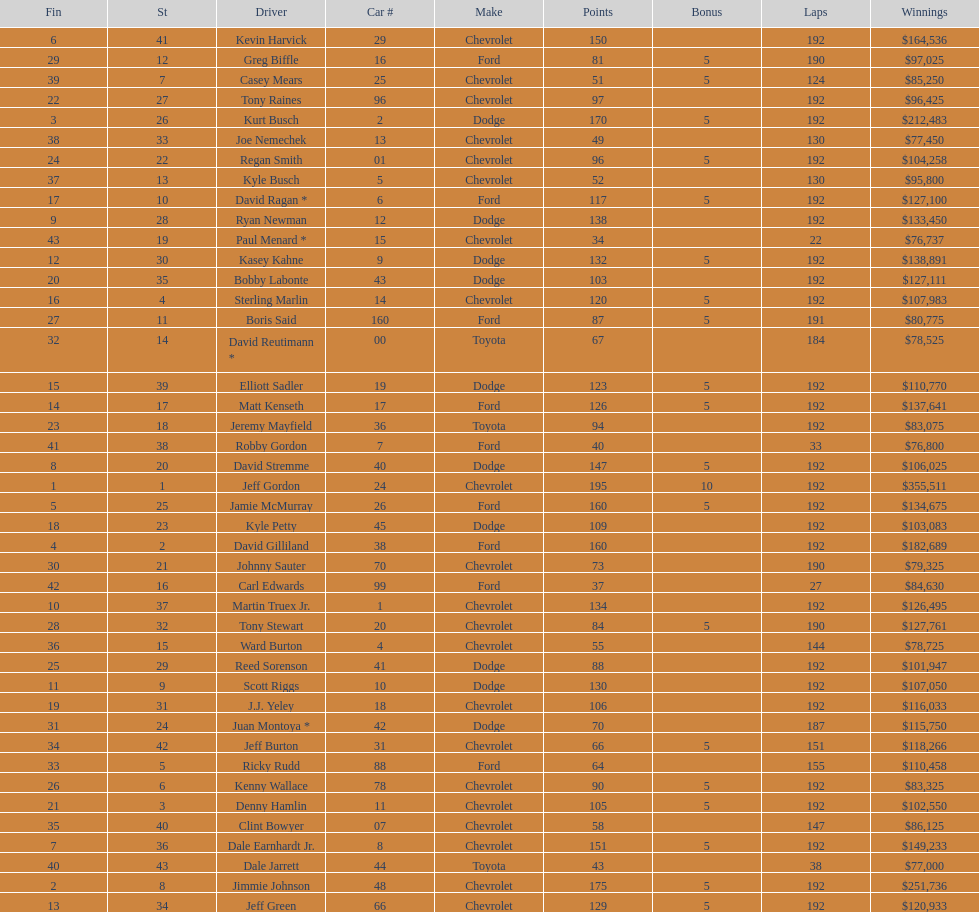What was the make of both jeff gordon's and jimmie johnson's race car? Chevrolet. Write the full table. {'header': ['Fin', 'St', 'Driver', 'Car #', 'Make', 'Points', 'Bonus', 'Laps', 'Winnings'], 'rows': [['6', '41', 'Kevin Harvick', '29', 'Chevrolet', '150', '', '192', '$164,536'], ['29', '12', 'Greg Biffle', '16', 'Ford', '81', '5', '190', '$97,025'], ['39', '7', 'Casey Mears', '25', 'Chevrolet', '51', '5', '124', '$85,250'], ['22', '27', 'Tony Raines', '96', 'Chevrolet', '97', '', '192', '$96,425'], ['3', '26', 'Kurt Busch', '2', 'Dodge', '170', '5', '192', '$212,483'], ['38', '33', 'Joe Nemechek', '13', 'Chevrolet', '49', '', '130', '$77,450'], ['24', '22', 'Regan Smith', '01', 'Chevrolet', '96', '5', '192', '$104,258'], ['37', '13', 'Kyle Busch', '5', 'Chevrolet', '52', '', '130', '$95,800'], ['17', '10', 'David Ragan *', '6', 'Ford', '117', '5', '192', '$127,100'], ['9', '28', 'Ryan Newman', '12', 'Dodge', '138', '', '192', '$133,450'], ['43', '19', 'Paul Menard *', '15', 'Chevrolet', '34', '', '22', '$76,737'], ['12', '30', 'Kasey Kahne', '9', 'Dodge', '132', '5', '192', '$138,891'], ['20', '35', 'Bobby Labonte', '43', 'Dodge', '103', '', '192', '$127,111'], ['16', '4', 'Sterling Marlin', '14', 'Chevrolet', '120', '5', '192', '$107,983'], ['27', '11', 'Boris Said', '160', 'Ford', '87', '5', '191', '$80,775'], ['32', '14', 'David Reutimann *', '00', 'Toyota', '67', '', '184', '$78,525'], ['15', '39', 'Elliott Sadler', '19', 'Dodge', '123', '5', '192', '$110,770'], ['14', '17', 'Matt Kenseth', '17', 'Ford', '126', '5', '192', '$137,641'], ['23', '18', 'Jeremy Mayfield', '36', 'Toyota', '94', '', '192', '$83,075'], ['41', '38', 'Robby Gordon', '7', 'Ford', '40', '', '33', '$76,800'], ['8', '20', 'David Stremme', '40', 'Dodge', '147', '5', '192', '$106,025'], ['1', '1', 'Jeff Gordon', '24', 'Chevrolet', '195', '10', '192', '$355,511'], ['5', '25', 'Jamie McMurray', '26', 'Ford', '160', '5', '192', '$134,675'], ['18', '23', 'Kyle Petty', '45', 'Dodge', '109', '', '192', '$103,083'], ['4', '2', 'David Gilliland', '38', 'Ford', '160', '', '192', '$182,689'], ['30', '21', 'Johnny Sauter', '70', 'Chevrolet', '73', '', '190', '$79,325'], ['42', '16', 'Carl Edwards', '99', 'Ford', '37', '', '27', '$84,630'], ['10', '37', 'Martin Truex Jr.', '1', 'Chevrolet', '134', '', '192', '$126,495'], ['28', '32', 'Tony Stewart', '20', 'Chevrolet', '84', '5', '190', '$127,761'], ['36', '15', 'Ward Burton', '4', 'Chevrolet', '55', '', '144', '$78,725'], ['25', '29', 'Reed Sorenson', '41', 'Dodge', '88', '', '192', '$101,947'], ['11', '9', 'Scott Riggs', '10', 'Dodge', '130', '', '192', '$107,050'], ['19', '31', 'J.J. Yeley', '18', 'Chevrolet', '106', '', '192', '$116,033'], ['31', '24', 'Juan Montoya *', '42', 'Dodge', '70', '', '187', '$115,750'], ['34', '42', 'Jeff Burton', '31', 'Chevrolet', '66', '5', '151', '$118,266'], ['33', '5', 'Ricky Rudd', '88', 'Ford', '64', '', '155', '$110,458'], ['26', '6', 'Kenny Wallace', '78', 'Chevrolet', '90', '5', '192', '$83,325'], ['21', '3', 'Denny Hamlin', '11', 'Chevrolet', '105', '5', '192', '$102,550'], ['35', '40', 'Clint Bowyer', '07', 'Chevrolet', '58', '', '147', '$86,125'], ['7', '36', 'Dale Earnhardt Jr.', '8', 'Chevrolet', '151', '5', '192', '$149,233'], ['40', '43', 'Dale Jarrett', '44', 'Toyota', '43', '', '38', '$77,000'], ['2', '8', 'Jimmie Johnson', '48', 'Chevrolet', '175', '5', '192', '$251,736'], ['13', '34', 'Jeff Green', '66', 'Chevrolet', '129', '5', '192', '$120,933']]} 